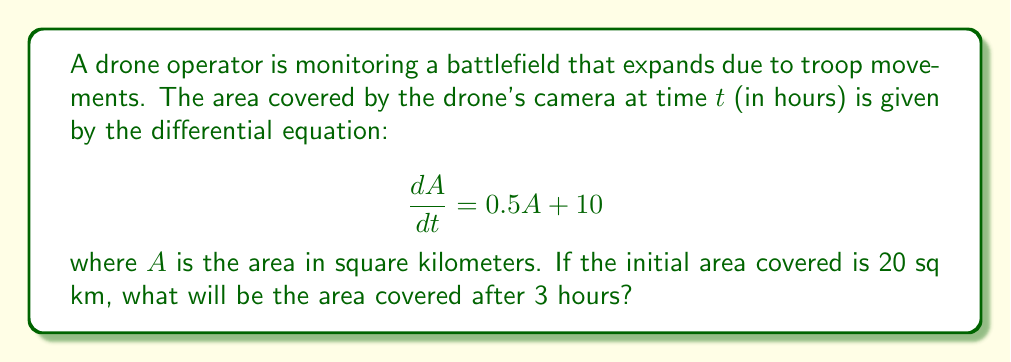Teach me how to tackle this problem. To solve this problem, we need to use the given differential equation and initial condition:

1) The differential equation is: $\frac{dA}{dt} = 0.5A + 10$

2) This is a linear first-order differential equation of the form $\frac{dy}{dx} + P(x)y = Q(x)$
   Here, $P(t) = -0.5$ and $Q(t) = 10$

3) The general solution for this type of equation is:
   $A = e^{-\int P(t)dt}(\int Q(t)e^{\int P(t)dt}dt + C)$

4) Solving the integrals:
   $\int P(t)dt = \int -0.5dt = -0.5t$
   $e^{\int P(t)dt} = e^{-0.5t}$

5) Substituting into the general solution:
   $A = e^{0.5t}(\int 10e^{-0.5t}dt + C)$
   $= e^{0.5t}(-20e^{-0.5t} + C)$
   $= -20 + Ce^{0.5t}$

6) Using the initial condition $A(0) = 20$:
   $20 = -20 + C$
   $C = 40$

7) Therefore, the particular solution is:
   $A(t) = -20 + 40e^{0.5t}$

8) To find the area after 3 hours, substitute $t=3$:
   $A(3) = -20 + 40e^{0.5(3)}$
   $= -20 + 40e^{1.5}$
   $\approx 158.88$ sq km
Answer: $158.88$ sq km 